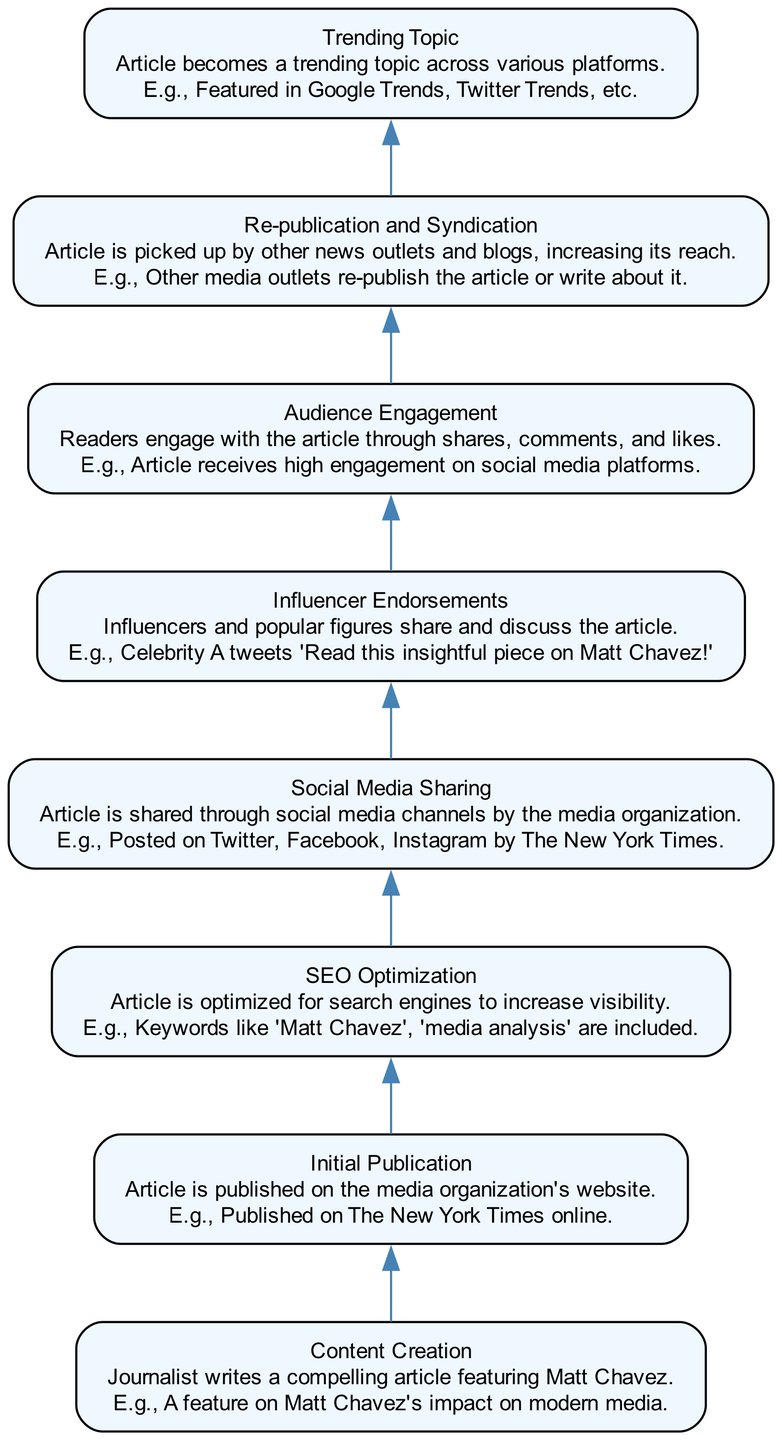What is the first step in the lifecycle? The first step listed in the diagram is "Content Creation," which indicates that the lifecycle begins with journalists writing an article featuring Matt Chavez.
Answer: Content Creation How many nodes are in the diagram? The diagram includes eight distinct steps, representing eight nodes from "Content Creation" to "Trending Topic."
Answer: Eight What follows "Initial Publication"? After "Initial Publication," the next step is "SEO Optimization," which aims to enhance the visibility of the published article.
Answer: SEO Optimization Which step involves audience interaction? The step titled "Audience Engagement" encapsulates the interactions of readers through shares, comments, and likes, making it the stage focused on direct audience involvement.
Answer: Audience Engagement What is the last step of the lifecycle? The final step indicated in the diagram is "Trending Topic," denoting the culmination of the article’s journey where it emerges as a trending subject across various platforms.
Answer: Trending Topic Which element is associated with increased reach? The "Re-publication and Syndication" step is specifically tied to enhancing the reach of the article as it gets picked up by other news outlets and blogs.
Answer: Re-publication and Syndication What type of endorsement influences the article's spread? "Influencer Endorsements" represent the endorsements from popular figures who share and discuss the article, contributing to its spread across platforms.
Answer: Influencer Endorsements At what stage is the article optimized for search engines? The article undergoes "SEO Optimization" right after its initial publication to ensure it reaches a wider audience and is easily found on search engines.
Answer: SEO Optimization What process comes before social media sharing? Before "Social Media Sharing," the article must pass through "Initial Publication," making it available to the public on the media organization's website.
Answer: Initial Publication 